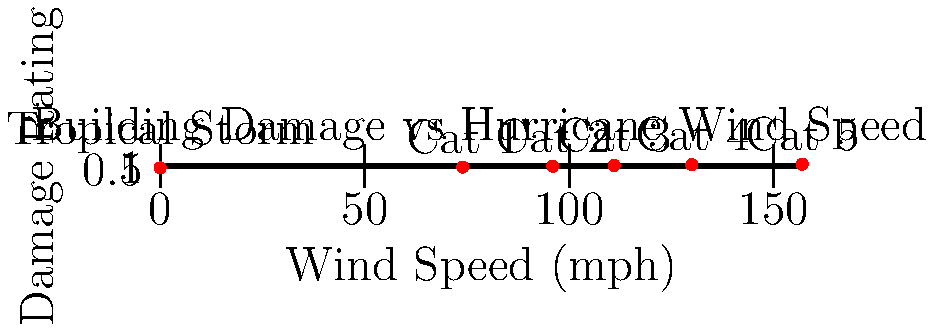Based on the graph showing the relationship between hurricane wind speeds and building damage ratings, which category of hurricane would likely cause approximately 70% damage to typical structures in New Orleans? To answer this question, we need to follow these steps:

1. Understand the graph:
   - The x-axis represents wind speed in mph
   - The y-axis represents the damage rating from 0 to 1 (0% to 100%)
   - Each point on the graph represents a hurricane category

2. Locate 70% damage on the y-axis:
   - 70% damage corresponds to a damage rating of 0.7 on the y-axis

3. Find the closest point to 0.7 on the y-axis:
   - Moving horizontally from 0.7, we encounter a point between "Cat 2" and "Cat 3"
   - This point is closer to "Cat 3"

4. Identify the hurricane category:
   - The closest category to 70% damage is Category 3

5. Verify the wind speed:
   - Category 3 hurricanes have wind speeds starting at 111 mph

Therefore, a Category 3 hurricane, with wind speeds of 111-129 mph, would likely cause approximately 70% damage to typical structures in New Orleans.
Answer: Category 3 hurricane 